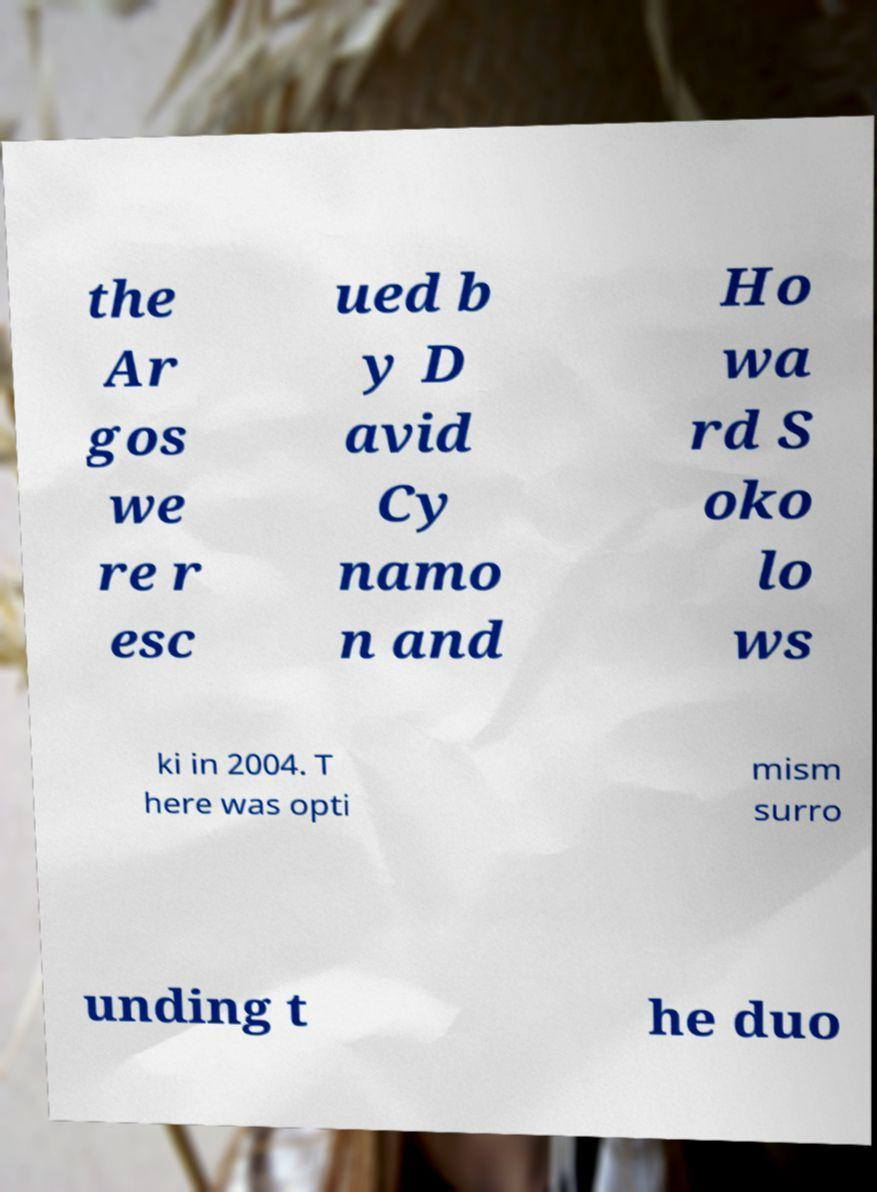There's text embedded in this image that I need extracted. Can you transcribe it verbatim? the Ar gos we re r esc ued b y D avid Cy namo n and Ho wa rd S oko lo ws ki in 2004. T here was opti mism surro unding t he duo 